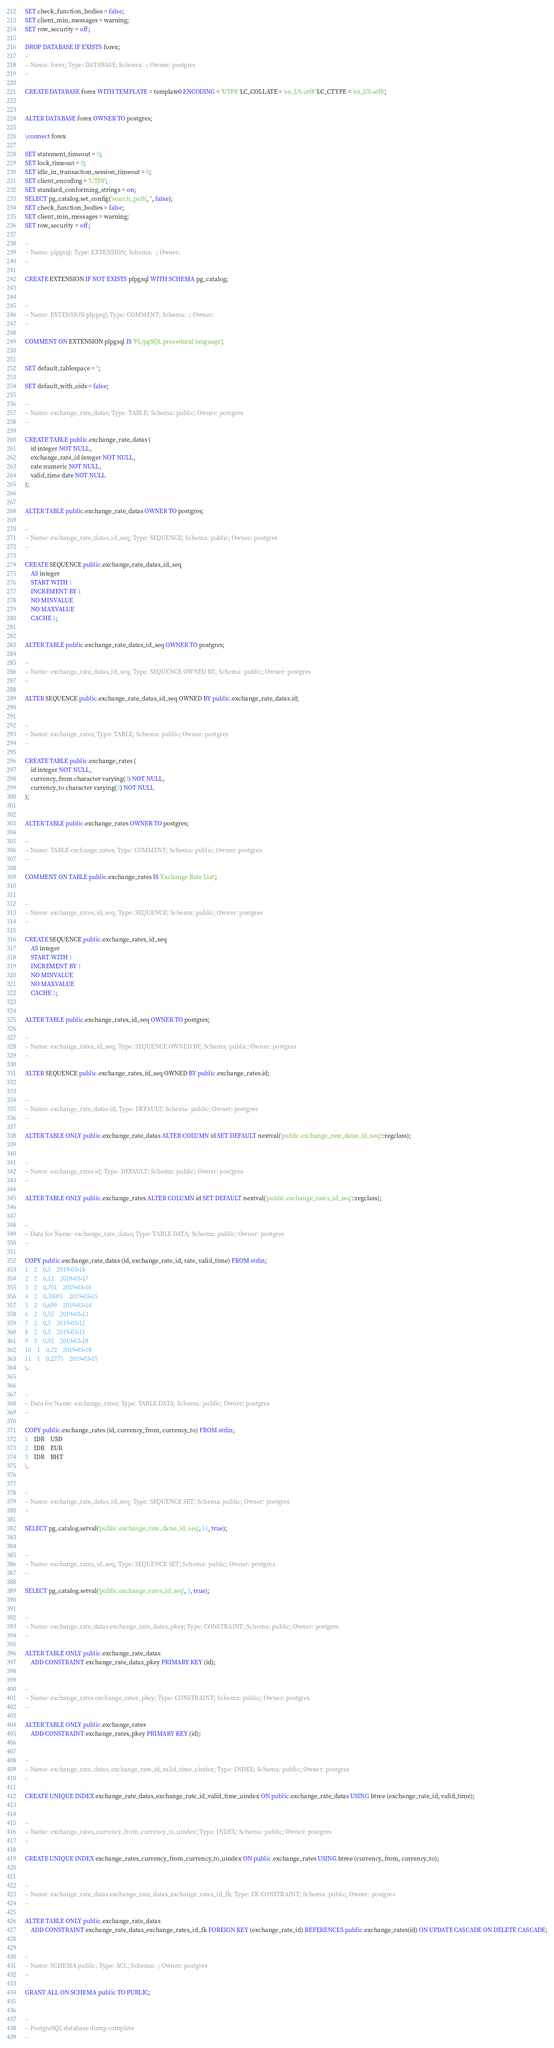Convert code to text. <code><loc_0><loc_0><loc_500><loc_500><_SQL_>SET check_function_bodies = false;
SET client_min_messages = warning;
SET row_security = off;

DROP DATABASE IF EXISTS forex;
--
-- Name: forex; Type: DATABASE; Schema: -; Owner: postgres
--

CREATE DATABASE forex WITH TEMPLATE = template0 ENCODING = 'UTF8' LC_COLLATE = 'en_US.utf8' LC_CTYPE = 'en_US.utf8';


ALTER DATABASE forex OWNER TO postgres;

\connect forex

SET statement_timeout = 0;
SET lock_timeout = 0;
SET idle_in_transaction_session_timeout = 0;
SET client_encoding = 'UTF8';
SET standard_conforming_strings = on;
SELECT pg_catalog.set_config('search_path', '', false);
SET check_function_bodies = false;
SET client_min_messages = warning;
SET row_security = off;

--
-- Name: plpgsql; Type: EXTENSION; Schema: -; Owner: 
--

CREATE EXTENSION IF NOT EXISTS plpgsql WITH SCHEMA pg_catalog;


--
-- Name: EXTENSION plpgsql; Type: COMMENT; Schema: -; Owner: 
--

COMMENT ON EXTENSION plpgsql IS 'PL/pgSQL procedural language';


SET default_tablespace = '';

SET default_with_oids = false;

--
-- Name: exchange_rate_datas; Type: TABLE; Schema: public; Owner: postgres
--

CREATE TABLE public.exchange_rate_datas (
    id integer NOT NULL,
    exchange_rate_id integer NOT NULL,
    rate numeric NOT NULL,
    valid_time date NOT NULL
);


ALTER TABLE public.exchange_rate_datas OWNER TO postgres;

--
-- Name: exchange_rate_datas_id_seq; Type: SEQUENCE; Schema: public; Owner: postgres
--

CREATE SEQUENCE public.exchange_rate_datas_id_seq
    AS integer
    START WITH 1
    INCREMENT BY 1
    NO MINVALUE
    NO MAXVALUE
    CACHE 1;


ALTER TABLE public.exchange_rate_datas_id_seq OWNER TO postgres;

--
-- Name: exchange_rate_datas_id_seq; Type: SEQUENCE OWNED BY; Schema: public; Owner: postgres
--

ALTER SEQUENCE public.exchange_rate_datas_id_seq OWNED BY public.exchange_rate_datas.id;


--
-- Name: exchange_rates; Type: TABLE; Schema: public; Owner: postgres
--

CREATE TABLE public.exchange_rates (
    id integer NOT NULL,
    currency_from character varying(3) NOT NULL,
    currency_to character varying(3) NOT NULL
);


ALTER TABLE public.exchange_rates OWNER TO postgres;

--
-- Name: TABLE exchange_rates; Type: COMMENT; Schema: public; Owner: postgres
--

COMMENT ON TABLE public.exchange_rates IS 'Exchange Rate List';


--
-- Name: exchange_rates_id_seq; Type: SEQUENCE; Schema: public; Owner: postgres
--

CREATE SEQUENCE public.exchange_rates_id_seq
    AS integer
    START WITH 1
    INCREMENT BY 1
    NO MINVALUE
    NO MAXVALUE
    CACHE 1;


ALTER TABLE public.exchange_rates_id_seq OWNER TO postgres;

--
-- Name: exchange_rates_id_seq; Type: SEQUENCE OWNED BY; Schema: public; Owner: postgres
--

ALTER SEQUENCE public.exchange_rates_id_seq OWNED BY public.exchange_rates.id;


--
-- Name: exchange_rate_datas id; Type: DEFAULT; Schema: public; Owner: postgres
--

ALTER TABLE ONLY public.exchange_rate_datas ALTER COLUMN id SET DEFAULT nextval('public.exchange_rate_datas_id_seq'::regclass);


--
-- Name: exchange_rates id; Type: DEFAULT; Schema: public; Owner: postgres
--

ALTER TABLE ONLY public.exchange_rates ALTER COLUMN id SET DEFAULT nextval('public.exchange_rates_id_seq'::regclass);


--
-- Data for Name: exchange_rate_datas; Type: TABLE DATA; Schema: public; Owner: postgres
--

COPY public.exchange_rate_datas (id, exchange_rate_id, rate, valid_time) FROM stdin;
1	2	0.5	2019-03-18
2	2	0.12	2019-03-17
3	2	0.701	2019-03-16
4	2	0.70001	2019-03-15
5	2	0.699	2019-03-14
6	2	0.55	2019-03-13
7	2	0.5	2019-03-12
8	2	0.5	2019-03-11
9	3	0.92	2019-03-18
10	1	0.22	2019-03-18
11	1	0.2775	2019-03-15
\.


--
-- Data for Name: exchange_rates; Type: TABLE DATA; Schema: public; Owner: postgres
--

COPY public.exchange_rates (id, currency_from, currency_to) FROM stdin;
1	IDR	USD
2	IDR	EUR
3	IDR	BHT
\.


--
-- Name: exchange_rate_datas_id_seq; Type: SEQUENCE SET; Schema: public; Owner: postgres
--

SELECT pg_catalog.setval('public.exchange_rate_datas_id_seq', 11, true);


--
-- Name: exchange_rates_id_seq; Type: SEQUENCE SET; Schema: public; Owner: postgres
--

SELECT pg_catalog.setval('public.exchange_rates_id_seq', 3, true);


--
-- Name: exchange_rate_datas exchange_rate_datas_pkey; Type: CONSTRAINT; Schema: public; Owner: postgres
--

ALTER TABLE ONLY public.exchange_rate_datas
    ADD CONSTRAINT exchange_rate_datas_pkey PRIMARY KEY (id);


--
-- Name: exchange_rates exchange_rates_pkey; Type: CONSTRAINT; Schema: public; Owner: postgres
--

ALTER TABLE ONLY public.exchange_rates
    ADD CONSTRAINT exchange_rates_pkey PRIMARY KEY (id);


--
-- Name: exchange_rate_datas_exchange_rate_id_valid_time_uindex; Type: INDEX; Schema: public; Owner: postgres
--

CREATE UNIQUE INDEX exchange_rate_datas_exchange_rate_id_valid_time_uindex ON public.exchange_rate_datas USING btree (exchange_rate_id, valid_time);


--
-- Name: exchange_rates_currency_from_currency_to_uindex; Type: INDEX; Schema: public; Owner: postgres
--

CREATE UNIQUE INDEX exchange_rates_currency_from_currency_to_uindex ON public.exchange_rates USING btree (currency_from, currency_to);


--
-- Name: exchange_rate_datas exchange_rate_datas_exchange_rates_id_fk; Type: FK CONSTRAINT; Schema: public; Owner: postgres
--

ALTER TABLE ONLY public.exchange_rate_datas
    ADD CONSTRAINT exchange_rate_datas_exchange_rates_id_fk FOREIGN KEY (exchange_rate_id) REFERENCES public.exchange_rates(id) ON UPDATE CASCADE ON DELETE CASCADE;


--
-- Name: SCHEMA public; Type: ACL; Schema: -; Owner: postgres
--

GRANT ALL ON SCHEMA public TO PUBLIC;


--
-- PostgreSQL database dump complete
--

</code> 